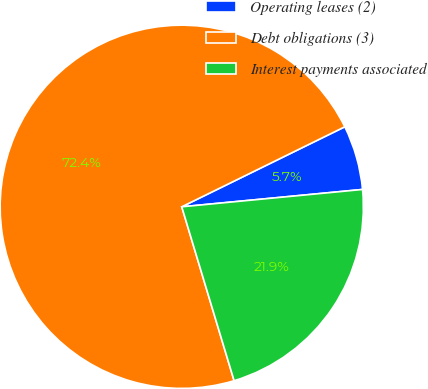Convert chart to OTSL. <chart><loc_0><loc_0><loc_500><loc_500><pie_chart><fcel>Operating leases (2)<fcel>Debt obligations (3)<fcel>Interest payments associated<nl><fcel>5.74%<fcel>72.4%<fcel>21.87%<nl></chart> 